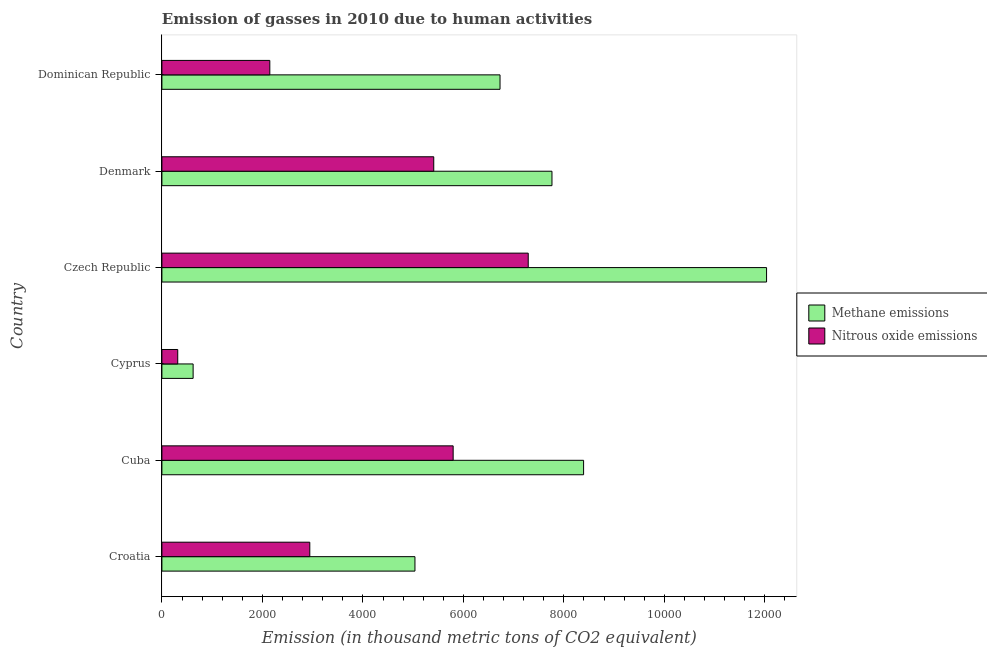Are the number of bars per tick equal to the number of legend labels?
Offer a terse response. Yes. How many bars are there on the 2nd tick from the bottom?
Keep it short and to the point. 2. What is the label of the 6th group of bars from the top?
Ensure brevity in your answer.  Croatia. What is the amount of methane emissions in Cuba?
Provide a succinct answer. 8392.1. Across all countries, what is the maximum amount of methane emissions?
Ensure brevity in your answer.  1.20e+04. Across all countries, what is the minimum amount of nitrous oxide emissions?
Your response must be concise. 315.2. In which country was the amount of methane emissions maximum?
Provide a short and direct response. Czech Republic. In which country was the amount of nitrous oxide emissions minimum?
Offer a terse response. Cyprus. What is the total amount of methane emissions in the graph?
Provide a succinct answer. 4.06e+04. What is the difference between the amount of methane emissions in Croatia and that in Cuba?
Provide a short and direct response. -3356.1. What is the difference between the amount of methane emissions in Czech Republic and the amount of nitrous oxide emissions in Cuba?
Make the answer very short. 6237.2. What is the average amount of methane emissions per country?
Provide a succinct answer. 6762.48. What is the difference between the amount of methane emissions and amount of nitrous oxide emissions in Denmark?
Your answer should be very brief. 2352.9. In how many countries, is the amount of methane emissions greater than 6000 thousand metric tons?
Offer a terse response. 4. What is the ratio of the amount of nitrous oxide emissions in Cyprus to that in Czech Republic?
Give a very brief answer. 0.04. Is the amount of nitrous oxide emissions in Croatia less than that in Cyprus?
Ensure brevity in your answer.  No. What is the difference between the highest and the second highest amount of nitrous oxide emissions?
Your response must be concise. 1494.3. What is the difference between the highest and the lowest amount of methane emissions?
Ensure brevity in your answer.  1.14e+04. What does the 2nd bar from the top in Czech Republic represents?
Make the answer very short. Methane emissions. What does the 2nd bar from the bottom in Cyprus represents?
Offer a terse response. Nitrous oxide emissions. What is the difference between two consecutive major ticks on the X-axis?
Give a very brief answer. 2000. Are the values on the major ticks of X-axis written in scientific E-notation?
Offer a very short reply. No. What is the title of the graph?
Make the answer very short. Emission of gasses in 2010 due to human activities. What is the label or title of the X-axis?
Make the answer very short. Emission (in thousand metric tons of CO2 equivalent). What is the label or title of the Y-axis?
Ensure brevity in your answer.  Country. What is the Emission (in thousand metric tons of CO2 equivalent) in Methane emissions in Croatia?
Make the answer very short. 5036. What is the Emission (in thousand metric tons of CO2 equivalent) of Nitrous oxide emissions in Croatia?
Offer a terse response. 2943.3. What is the Emission (in thousand metric tons of CO2 equivalent) of Methane emissions in Cuba?
Your response must be concise. 8392.1. What is the Emission (in thousand metric tons of CO2 equivalent) of Nitrous oxide emissions in Cuba?
Provide a short and direct response. 5796.2. What is the Emission (in thousand metric tons of CO2 equivalent) in Methane emissions in Cyprus?
Keep it short and to the point. 621.4. What is the Emission (in thousand metric tons of CO2 equivalent) in Nitrous oxide emissions in Cyprus?
Your answer should be compact. 315.2. What is the Emission (in thousand metric tons of CO2 equivalent) in Methane emissions in Czech Republic?
Make the answer very short. 1.20e+04. What is the Emission (in thousand metric tons of CO2 equivalent) of Nitrous oxide emissions in Czech Republic?
Your answer should be compact. 7290.5. What is the Emission (in thousand metric tons of CO2 equivalent) of Methane emissions in Denmark?
Provide a succinct answer. 7762.9. What is the Emission (in thousand metric tons of CO2 equivalent) of Nitrous oxide emissions in Denmark?
Keep it short and to the point. 5410. What is the Emission (in thousand metric tons of CO2 equivalent) in Methane emissions in Dominican Republic?
Provide a succinct answer. 6729.1. What is the Emission (in thousand metric tons of CO2 equivalent) of Nitrous oxide emissions in Dominican Republic?
Your answer should be compact. 2147.5. Across all countries, what is the maximum Emission (in thousand metric tons of CO2 equivalent) in Methane emissions?
Your response must be concise. 1.20e+04. Across all countries, what is the maximum Emission (in thousand metric tons of CO2 equivalent) in Nitrous oxide emissions?
Give a very brief answer. 7290.5. Across all countries, what is the minimum Emission (in thousand metric tons of CO2 equivalent) in Methane emissions?
Ensure brevity in your answer.  621.4. Across all countries, what is the minimum Emission (in thousand metric tons of CO2 equivalent) of Nitrous oxide emissions?
Provide a succinct answer. 315.2. What is the total Emission (in thousand metric tons of CO2 equivalent) in Methane emissions in the graph?
Ensure brevity in your answer.  4.06e+04. What is the total Emission (in thousand metric tons of CO2 equivalent) in Nitrous oxide emissions in the graph?
Ensure brevity in your answer.  2.39e+04. What is the difference between the Emission (in thousand metric tons of CO2 equivalent) of Methane emissions in Croatia and that in Cuba?
Keep it short and to the point. -3356.1. What is the difference between the Emission (in thousand metric tons of CO2 equivalent) of Nitrous oxide emissions in Croatia and that in Cuba?
Offer a terse response. -2852.9. What is the difference between the Emission (in thousand metric tons of CO2 equivalent) of Methane emissions in Croatia and that in Cyprus?
Offer a very short reply. 4414.6. What is the difference between the Emission (in thousand metric tons of CO2 equivalent) in Nitrous oxide emissions in Croatia and that in Cyprus?
Keep it short and to the point. 2628.1. What is the difference between the Emission (in thousand metric tons of CO2 equivalent) of Methane emissions in Croatia and that in Czech Republic?
Offer a very short reply. -6997.4. What is the difference between the Emission (in thousand metric tons of CO2 equivalent) in Nitrous oxide emissions in Croatia and that in Czech Republic?
Offer a terse response. -4347.2. What is the difference between the Emission (in thousand metric tons of CO2 equivalent) in Methane emissions in Croatia and that in Denmark?
Give a very brief answer. -2726.9. What is the difference between the Emission (in thousand metric tons of CO2 equivalent) in Nitrous oxide emissions in Croatia and that in Denmark?
Make the answer very short. -2466.7. What is the difference between the Emission (in thousand metric tons of CO2 equivalent) of Methane emissions in Croatia and that in Dominican Republic?
Provide a short and direct response. -1693.1. What is the difference between the Emission (in thousand metric tons of CO2 equivalent) of Nitrous oxide emissions in Croatia and that in Dominican Republic?
Your answer should be very brief. 795.8. What is the difference between the Emission (in thousand metric tons of CO2 equivalent) of Methane emissions in Cuba and that in Cyprus?
Provide a succinct answer. 7770.7. What is the difference between the Emission (in thousand metric tons of CO2 equivalent) of Nitrous oxide emissions in Cuba and that in Cyprus?
Your response must be concise. 5481. What is the difference between the Emission (in thousand metric tons of CO2 equivalent) of Methane emissions in Cuba and that in Czech Republic?
Provide a succinct answer. -3641.3. What is the difference between the Emission (in thousand metric tons of CO2 equivalent) in Nitrous oxide emissions in Cuba and that in Czech Republic?
Offer a very short reply. -1494.3. What is the difference between the Emission (in thousand metric tons of CO2 equivalent) in Methane emissions in Cuba and that in Denmark?
Your answer should be compact. 629.2. What is the difference between the Emission (in thousand metric tons of CO2 equivalent) of Nitrous oxide emissions in Cuba and that in Denmark?
Your answer should be compact. 386.2. What is the difference between the Emission (in thousand metric tons of CO2 equivalent) in Methane emissions in Cuba and that in Dominican Republic?
Offer a very short reply. 1663. What is the difference between the Emission (in thousand metric tons of CO2 equivalent) in Nitrous oxide emissions in Cuba and that in Dominican Republic?
Make the answer very short. 3648.7. What is the difference between the Emission (in thousand metric tons of CO2 equivalent) of Methane emissions in Cyprus and that in Czech Republic?
Offer a terse response. -1.14e+04. What is the difference between the Emission (in thousand metric tons of CO2 equivalent) of Nitrous oxide emissions in Cyprus and that in Czech Republic?
Provide a short and direct response. -6975.3. What is the difference between the Emission (in thousand metric tons of CO2 equivalent) in Methane emissions in Cyprus and that in Denmark?
Ensure brevity in your answer.  -7141.5. What is the difference between the Emission (in thousand metric tons of CO2 equivalent) of Nitrous oxide emissions in Cyprus and that in Denmark?
Provide a succinct answer. -5094.8. What is the difference between the Emission (in thousand metric tons of CO2 equivalent) in Methane emissions in Cyprus and that in Dominican Republic?
Ensure brevity in your answer.  -6107.7. What is the difference between the Emission (in thousand metric tons of CO2 equivalent) in Nitrous oxide emissions in Cyprus and that in Dominican Republic?
Offer a very short reply. -1832.3. What is the difference between the Emission (in thousand metric tons of CO2 equivalent) of Methane emissions in Czech Republic and that in Denmark?
Keep it short and to the point. 4270.5. What is the difference between the Emission (in thousand metric tons of CO2 equivalent) in Nitrous oxide emissions in Czech Republic and that in Denmark?
Your response must be concise. 1880.5. What is the difference between the Emission (in thousand metric tons of CO2 equivalent) in Methane emissions in Czech Republic and that in Dominican Republic?
Keep it short and to the point. 5304.3. What is the difference between the Emission (in thousand metric tons of CO2 equivalent) in Nitrous oxide emissions in Czech Republic and that in Dominican Republic?
Keep it short and to the point. 5143. What is the difference between the Emission (in thousand metric tons of CO2 equivalent) of Methane emissions in Denmark and that in Dominican Republic?
Offer a terse response. 1033.8. What is the difference between the Emission (in thousand metric tons of CO2 equivalent) of Nitrous oxide emissions in Denmark and that in Dominican Republic?
Provide a short and direct response. 3262.5. What is the difference between the Emission (in thousand metric tons of CO2 equivalent) in Methane emissions in Croatia and the Emission (in thousand metric tons of CO2 equivalent) in Nitrous oxide emissions in Cuba?
Provide a short and direct response. -760.2. What is the difference between the Emission (in thousand metric tons of CO2 equivalent) in Methane emissions in Croatia and the Emission (in thousand metric tons of CO2 equivalent) in Nitrous oxide emissions in Cyprus?
Your answer should be very brief. 4720.8. What is the difference between the Emission (in thousand metric tons of CO2 equivalent) of Methane emissions in Croatia and the Emission (in thousand metric tons of CO2 equivalent) of Nitrous oxide emissions in Czech Republic?
Your answer should be very brief. -2254.5. What is the difference between the Emission (in thousand metric tons of CO2 equivalent) of Methane emissions in Croatia and the Emission (in thousand metric tons of CO2 equivalent) of Nitrous oxide emissions in Denmark?
Offer a very short reply. -374. What is the difference between the Emission (in thousand metric tons of CO2 equivalent) in Methane emissions in Croatia and the Emission (in thousand metric tons of CO2 equivalent) in Nitrous oxide emissions in Dominican Republic?
Make the answer very short. 2888.5. What is the difference between the Emission (in thousand metric tons of CO2 equivalent) in Methane emissions in Cuba and the Emission (in thousand metric tons of CO2 equivalent) in Nitrous oxide emissions in Cyprus?
Offer a terse response. 8076.9. What is the difference between the Emission (in thousand metric tons of CO2 equivalent) in Methane emissions in Cuba and the Emission (in thousand metric tons of CO2 equivalent) in Nitrous oxide emissions in Czech Republic?
Your response must be concise. 1101.6. What is the difference between the Emission (in thousand metric tons of CO2 equivalent) in Methane emissions in Cuba and the Emission (in thousand metric tons of CO2 equivalent) in Nitrous oxide emissions in Denmark?
Offer a terse response. 2982.1. What is the difference between the Emission (in thousand metric tons of CO2 equivalent) of Methane emissions in Cuba and the Emission (in thousand metric tons of CO2 equivalent) of Nitrous oxide emissions in Dominican Republic?
Your answer should be very brief. 6244.6. What is the difference between the Emission (in thousand metric tons of CO2 equivalent) in Methane emissions in Cyprus and the Emission (in thousand metric tons of CO2 equivalent) in Nitrous oxide emissions in Czech Republic?
Keep it short and to the point. -6669.1. What is the difference between the Emission (in thousand metric tons of CO2 equivalent) in Methane emissions in Cyprus and the Emission (in thousand metric tons of CO2 equivalent) in Nitrous oxide emissions in Denmark?
Make the answer very short. -4788.6. What is the difference between the Emission (in thousand metric tons of CO2 equivalent) in Methane emissions in Cyprus and the Emission (in thousand metric tons of CO2 equivalent) in Nitrous oxide emissions in Dominican Republic?
Ensure brevity in your answer.  -1526.1. What is the difference between the Emission (in thousand metric tons of CO2 equivalent) of Methane emissions in Czech Republic and the Emission (in thousand metric tons of CO2 equivalent) of Nitrous oxide emissions in Denmark?
Give a very brief answer. 6623.4. What is the difference between the Emission (in thousand metric tons of CO2 equivalent) of Methane emissions in Czech Republic and the Emission (in thousand metric tons of CO2 equivalent) of Nitrous oxide emissions in Dominican Republic?
Provide a short and direct response. 9885.9. What is the difference between the Emission (in thousand metric tons of CO2 equivalent) of Methane emissions in Denmark and the Emission (in thousand metric tons of CO2 equivalent) of Nitrous oxide emissions in Dominican Republic?
Offer a terse response. 5615.4. What is the average Emission (in thousand metric tons of CO2 equivalent) of Methane emissions per country?
Give a very brief answer. 6762.48. What is the average Emission (in thousand metric tons of CO2 equivalent) of Nitrous oxide emissions per country?
Your answer should be very brief. 3983.78. What is the difference between the Emission (in thousand metric tons of CO2 equivalent) in Methane emissions and Emission (in thousand metric tons of CO2 equivalent) in Nitrous oxide emissions in Croatia?
Give a very brief answer. 2092.7. What is the difference between the Emission (in thousand metric tons of CO2 equivalent) in Methane emissions and Emission (in thousand metric tons of CO2 equivalent) in Nitrous oxide emissions in Cuba?
Your response must be concise. 2595.9. What is the difference between the Emission (in thousand metric tons of CO2 equivalent) of Methane emissions and Emission (in thousand metric tons of CO2 equivalent) of Nitrous oxide emissions in Cyprus?
Make the answer very short. 306.2. What is the difference between the Emission (in thousand metric tons of CO2 equivalent) in Methane emissions and Emission (in thousand metric tons of CO2 equivalent) in Nitrous oxide emissions in Czech Republic?
Offer a very short reply. 4742.9. What is the difference between the Emission (in thousand metric tons of CO2 equivalent) in Methane emissions and Emission (in thousand metric tons of CO2 equivalent) in Nitrous oxide emissions in Denmark?
Provide a succinct answer. 2352.9. What is the difference between the Emission (in thousand metric tons of CO2 equivalent) of Methane emissions and Emission (in thousand metric tons of CO2 equivalent) of Nitrous oxide emissions in Dominican Republic?
Ensure brevity in your answer.  4581.6. What is the ratio of the Emission (in thousand metric tons of CO2 equivalent) in Methane emissions in Croatia to that in Cuba?
Ensure brevity in your answer.  0.6. What is the ratio of the Emission (in thousand metric tons of CO2 equivalent) in Nitrous oxide emissions in Croatia to that in Cuba?
Ensure brevity in your answer.  0.51. What is the ratio of the Emission (in thousand metric tons of CO2 equivalent) in Methane emissions in Croatia to that in Cyprus?
Offer a terse response. 8.1. What is the ratio of the Emission (in thousand metric tons of CO2 equivalent) in Nitrous oxide emissions in Croatia to that in Cyprus?
Make the answer very short. 9.34. What is the ratio of the Emission (in thousand metric tons of CO2 equivalent) in Methane emissions in Croatia to that in Czech Republic?
Keep it short and to the point. 0.42. What is the ratio of the Emission (in thousand metric tons of CO2 equivalent) in Nitrous oxide emissions in Croatia to that in Czech Republic?
Offer a terse response. 0.4. What is the ratio of the Emission (in thousand metric tons of CO2 equivalent) in Methane emissions in Croatia to that in Denmark?
Offer a very short reply. 0.65. What is the ratio of the Emission (in thousand metric tons of CO2 equivalent) of Nitrous oxide emissions in Croatia to that in Denmark?
Provide a short and direct response. 0.54. What is the ratio of the Emission (in thousand metric tons of CO2 equivalent) of Methane emissions in Croatia to that in Dominican Republic?
Your response must be concise. 0.75. What is the ratio of the Emission (in thousand metric tons of CO2 equivalent) of Nitrous oxide emissions in Croatia to that in Dominican Republic?
Provide a short and direct response. 1.37. What is the ratio of the Emission (in thousand metric tons of CO2 equivalent) of Methane emissions in Cuba to that in Cyprus?
Ensure brevity in your answer.  13.51. What is the ratio of the Emission (in thousand metric tons of CO2 equivalent) of Nitrous oxide emissions in Cuba to that in Cyprus?
Make the answer very short. 18.39. What is the ratio of the Emission (in thousand metric tons of CO2 equivalent) of Methane emissions in Cuba to that in Czech Republic?
Keep it short and to the point. 0.7. What is the ratio of the Emission (in thousand metric tons of CO2 equivalent) of Nitrous oxide emissions in Cuba to that in Czech Republic?
Your response must be concise. 0.8. What is the ratio of the Emission (in thousand metric tons of CO2 equivalent) in Methane emissions in Cuba to that in Denmark?
Your response must be concise. 1.08. What is the ratio of the Emission (in thousand metric tons of CO2 equivalent) in Nitrous oxide emissions in Cuba to that in Denmark?
Your response must be concise. 1.07. What is the ratio of the Emission (in thousand metric tons of CO2 equivalent) in Methane emissions in Cuba to that in Dominican Republic?
Ensure brevity in your answer.  1.25. What is the ratio of the Emission (in thousand metric tons of CO2 equivalent) in Nitrous oxide emissions in Cuba to that in Dominican Republic?
Ensure brevity in your answer.  2.7. What is the ratio of the Emission (in thousand metric tons of CO2 equivalent) of Methane emissions in Cyprus to that in Czech Republic?
Make the answer very short. 0.05. What is the ratio of the Emission (in thousand metric tons of CO2 equivalent) in Nitrous oxide emissions in Cyprus to that in Czech Republic?
Keep it short and to the point. 0.04. What is the ratio of the Emission (in thousand metric tons of CO2 equivalent) in Nitrous oxide emissions in Cyprus to that in Denmark?
Offer a terse response. 0.06. What is the ratio of the Emission (in thousand metric tons of CO2 equivalent) in Methane emissions in Cyprus to that in Dominican Republic?
Provide a short and direct response. 0.09. What is the ratio of the Emission (in thousand metric tons of CO2 equivalent) in Nitrous oxide emissions in Cyprus to that in Dominican Republic?
Keep it short and to the point. 0.15. What is the ratio of the Emission (in thousand metric tons of CO2 equivalent) in Methane emissions in Czech Republic to that in Denmark?
Offer a terse response. 1.55. What is the ratio of the Emission (in thousand metric tons of CO2 equivalent) of Nitrous oxide emissions in Czech Republic to that in Denmark?
Provide a succinct answer. 1.35. What is the ratio of the Emission (in thousand metric tons of CO2 equivalent) of Methane emissions in Czech Republic to that in Dominican Republic?
Make the answer very short. 1.79. What is the ratio of the Emission (in thousand metric tons of CO2 equivalent) of Nitrous oxide emissions in Czech Republic to that in Dominican Republic?
Ensure brevity in your answer.  3.39. What is the ratio of the Emission (in thousand metric tons of CO2 equivalent) of Methane emissions in Denmark to that in Dominican Republic?
Your answer should be very brief. 1.15. What is the ratio of the Emission (in thousand metric tons of CO2 equivalent) in Nitrous oxide emissions in Denmark to that in Dominican Republic?
Offer a very short reply. 2.52. What is the difference between the highest and the second highest Emission (in thousand metric tons of CO2 equivalent) in Methane emissions?
Your answer should be very brief. 3641.3. What is the difference between the highest and the second highest Emission (in thousand metric tons of CO2 equivalent) of Nitrous oxide emissions?
Your answer should be very brief. 1494.3. What is the difference between the highest and the lowest Emission (in thousand metric tons of CO2 equivalent) of Methane emissions?
Offer a terse response. 1.14e+04. What is the difference between the highest and the lowest Emission (in thousand metric tons of CO2 equivalent) in Nitrous oxide emissions?
Ensure brevity in your answer.  6975.3. 